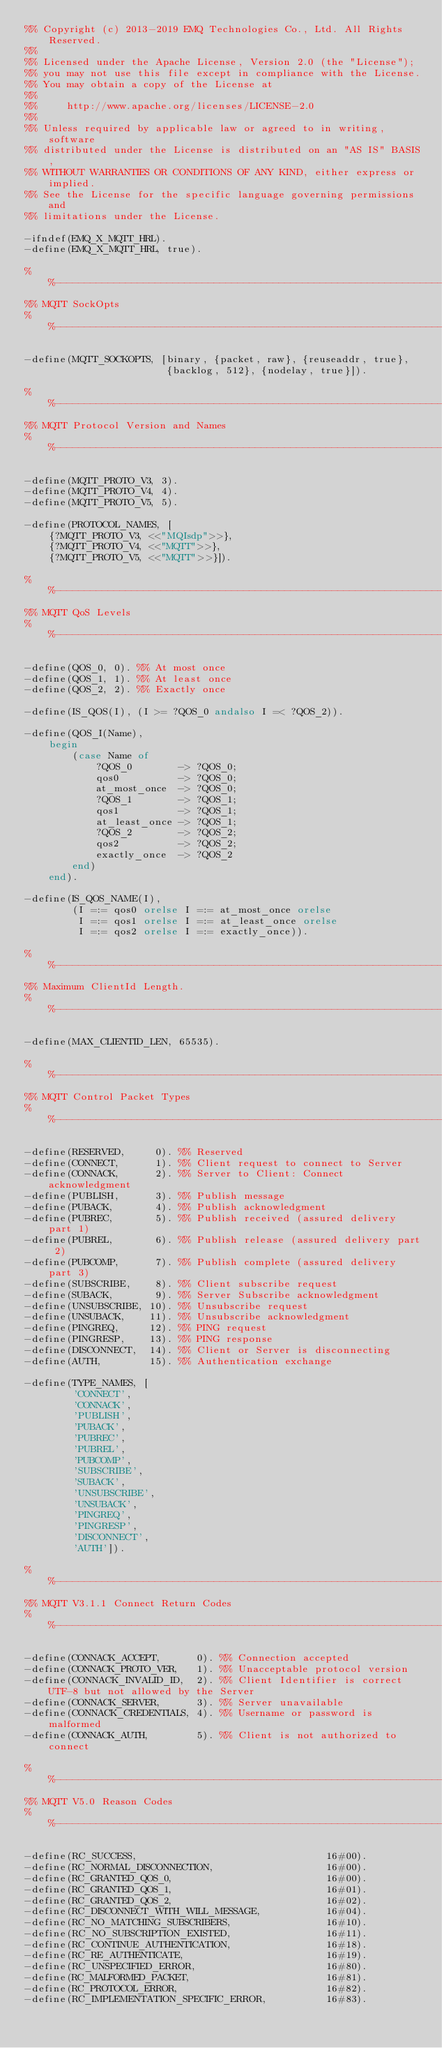Convert code to text. <code><loc_0><loc_0><loc_500><loc_500><_Erlang_>%% Copyright (c) 2013-2019 EMQ Technologies Co., Ltd. All Rights Reserved.
%%
%% Licensed under the Apache License, Version 2.0 (the "License");
%% you may not use this file except in compliance with the License.
%% You may obtain a copy of the License at
%%
%%     http://www.apache.org/licenses/LICENSE-2.0
%%
%% Unless required by applicable law or agreed to in writing, software
%% distributed under the License is distributed on an "AS IS" BASIS,
%% WITHOUT WARRANTIES OR CONDITIONS OF ANY KIND, either express or implied.
%% See the License for the specific language governing permissions and
%% limitations under the License.

-ifndef(EMQ_X_MQTT_HRL).
-define(EMQ_X_MQTT_HRL, true).

%%--------------------------------------------------------------------
%% MQTT SockOpts
%%--------------------------------------------------------------------

-define(MQTT_SOCKOPTS, [binary, {packet, raw}, {reuseaddr, true},
                        {backlog, 512}, {nodelay, true}]).

%%--------------------------------------------------------------------
%% MQTT Protocol Version and Names
%%--------------------------------------------------------------------

-define(MQTT_PROTO_V3, 3).
-define(MQTT_PROTO_V4, 4).
-define(MQTT_PROTO_V5, 5).

-define(PROTOCOL_NAMES, [
    {?MQTT_PROTO_V3, <<"MQIsdp">>},
    {?MQTT_PROTO_V4, <<"MQTT">>},
    {?MQTT_PROTO_V5, <<"MQTT">>}]).

%%--------------------------------------------------------------------
%% MQTT QoS Levels
%%--------------------------------------------------------------------

-define(QOS_0, 0). %% At most once
-define(QOS_1, 1). %% At least once
-define(QOS_2, 2). %% Exactly once

-define(IS_QOS(I), (I >= ?QOS_0 andalso I =< ?QOS_2)).

-define(QOS_I(Name),
    begin
        (case Name of
            ?QOS_0        -> ?QOS_0;
            qos0          -> ?QOS_0;
            at_most_once  -> ?QOS_0;
            ?QOS_1        -> ?QOS_1;
            qos1          -> ?QOS_1;
            at_least_once -> ?QOS_1;
            ?QOS_2        -> ?QOS_2;
            qos2          -> ?QOS_2;
            exactly_once  -> ?QOS_2
        end)
    end).

-define(IS_QOS_NAME(I),
        (I =:= qos0 orelse I =:= at_most_once orelse
         I =:= qos1 orelse I =:= at_least_once orelse
         I =:= qos2 orelse I =:= exactly_once)).

%%--------------------------------------------------------------------
%% Maximum ClientId Length.
%%--------------------------------------------------------------------

-define(MAX_CLIENTID_LEN, 65535).

%%--------------------------------------------------------------------
%% MQTT Control Packet Types
%%--------------------------------------------------------------------

-define(RESERVED,     0). %% Reserved
-define(CONNECT,      1). %% Client request to connect to Server
-define(CONNACK,      2). %% Server to Client: Connect acknowledgment
-define(PUBLISH,      3). %% Publish message
-define(PUBACK,       4). %% Publish acknowledgment
-define(PUBREC,       5). %% Publish received (assured delivery part 1)
-define(PUBREL,       6). %% Publish release (assured delivery part 2)
-define(PUBCOMP,      7). %% Publish complete (assured delivery part 3)
-define(SUBSCRIBE,    8). %% Client subscribe request
-define(SUBACK,       9). %% Server Subscribe acknowledgment
-define(UNSUBSCRIBE, 10). %% Unsubscribe request
-define(UNSUBACK,    11). %% Unsubscribe acknowledgment
-define(PINGREQ,     12). %% PING request
-define(PINGRESP,    13). %% PING response
-define(DISCONNECT,  14). %% Client or Server is disconnecting
-define(AUTH,        15). %% Authentication exchange

-define(TYPE_NAMES, [
        'CONNECT',
        'CONNACK',
        'PUBLISH',
        'PUBACK',
        'PUBREC',
        'PUBREL',
        'PUBCOMP',
        'SUBSCRIBE',
        'SUBACK',
        'UNSUBSCRIBE',
        'UNSUBACK',
        'PINGREQ',
        'PINGRESP',
        'DISCONNECT',
        'AUTH']).

%%--------------------------------------------------------------------
%% MQTT V3.1.1 Connect Return Codes
%%--------------------------------------------------------------------

-define(CONNACK_ACCEPT,      0). %% Connection accepted
-define(CONNACK_PROTO_VER,   1). %% Unacceptable protocol version
-define(CONNACK_INVALID_ID,  2). %% Client Identifier is correct UTF-8 but not allowed by the Server
-define(CONNACK_SERVER,      3). %% Server unavailable
-define(CONNACK_CREDENTIALS, 4). %% Username or password is malformed
-define(CONNACK_AUTH,        5). %% Client is not authorized to connect

%%--------------------------------------------------------------------
%% MQTT V5.0 Reason Codes
%%--------------------------------------------------------------------

-define(RC_SUCCESS,                                16#00).
-define(RC_NORMAL_DISCONNECTION,                   16#00).
-define(RC_GRANTED_QOS_0,                          16#00).
-define(RC_GRANTED_QOS_1,                          16#01).
-define(RC_GRANTED_QOS_2,                          16#02).
-define(RC_DISCONNECT_WITH_WILL_MESSAGE,           16#04).
-define(RC_NO_MATCHING_SUBSCRIBERS,                16#10).
-define(RC_NO_SUBSCRIPTION_EXISTED,                16#11).
-define(RC_CONTINUE_AUTHENTICATION,                16#18).
-define(RC_RE_AUTHENTICATE,                        16#19).
-define(RC_UNSPECIFIED_ERROR,                      16#80).
-define(RC_MALFORMED_PACKET,                       16#81).
-define(RC_PROTOCOL_ERROR,                         16#82).
-define(RC_IMPLEMENTATION_SPECIFIC_ERROR,          16#83).</code> 